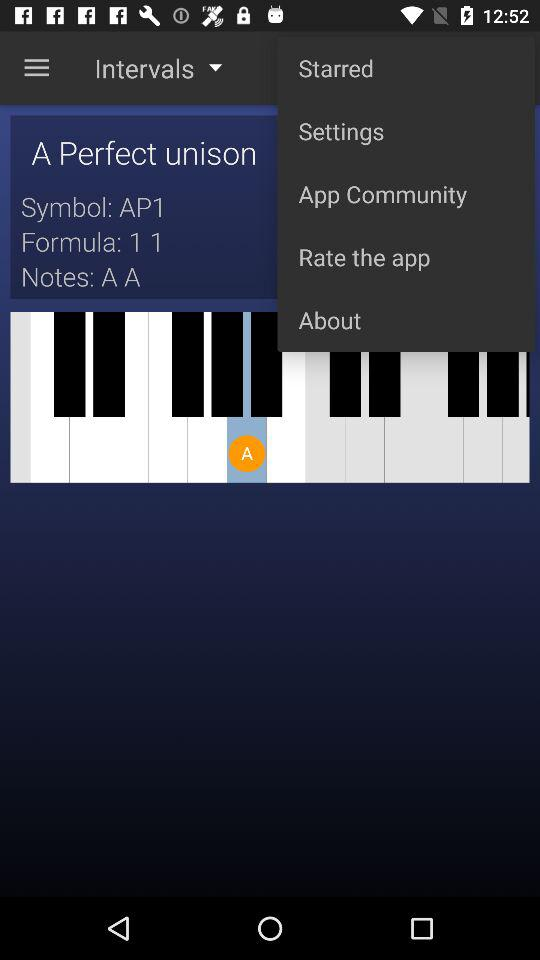What is the given "Symbol"? The given "Symbol" is "AP1". 